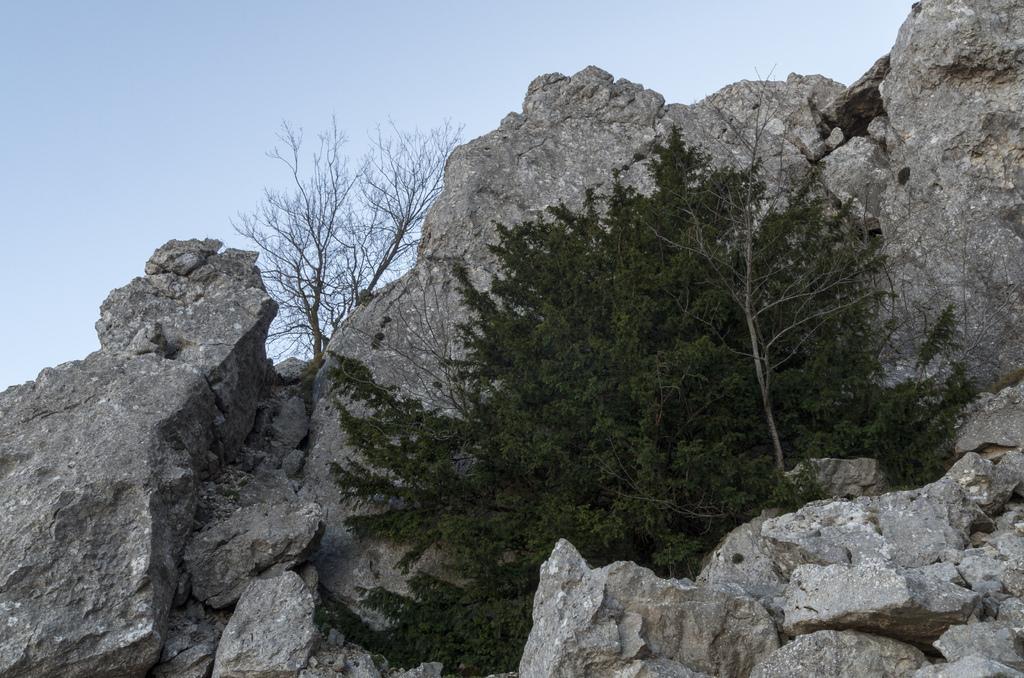Can you describe this image briefly? In this image there are rocks and trees. In the background there is the sky. 